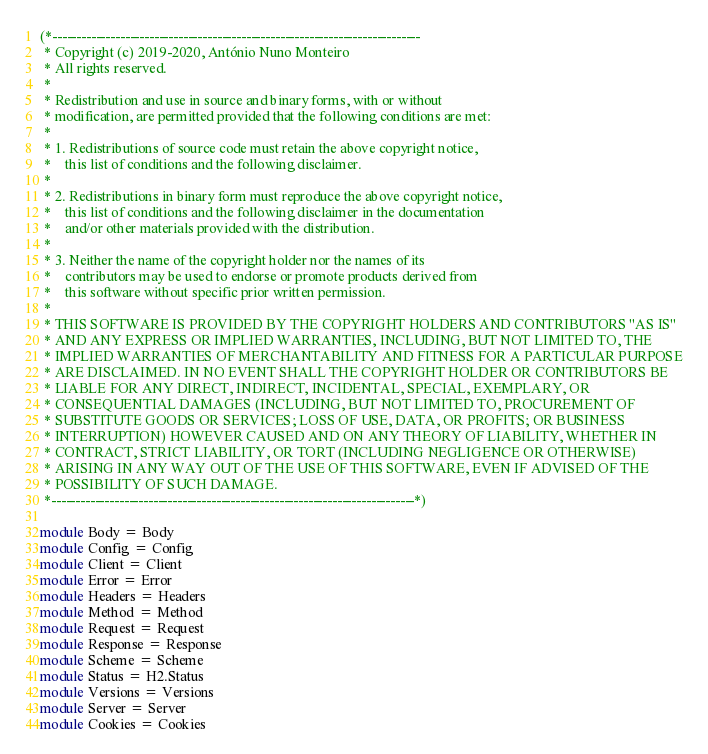<code> <loc_0><loc_0><loc_500><loc_500><_OCaml_>(*----------------------------------------------------------------------------
 * Copyright (c) 2019-2020, António Nuno Monteiro
 * All rights reserved.
 *
 * Redistribution and use in source and binary forms, with or without
 * modification, are permitted provided that the following conditions are met:
 *
 * 1. Redistributions of source code must retain the above copyright notice,
 *    this list of conditions and the following disclaimer.
 *
 * 2. Redistributions in binary form must reproduce the above copyright notice,
 *    this list of conditions and the following disclaimer in the documentation
 *    and/or other materials provided with the distribution.
 *
 * 3. Neither the name of the copyright holder nor the names of its
 *    contributors may be used to endorse or promote products derived from
 *    this software without specific prior written permission.
 *
 * THIS SOFTWARE IS PROVIDED BY THE COPYRIGHT HOLDERS AND CONTRIBUTORS "AS IS"
 * AND ANY EXPRESS OR IMPLIED WARRANTIES, INCLUDING, BUT NOT LIMITED TO, THE
 * IMPLIED WARRANTIES OF MERCHANTABILITY AND FITNESS FOR A PARTICULAR PURPOSE
 * ARE DISCLAIMED. IN NO EVENT SHALL THE COPYRIGHT HOLDER OR CONTRIBUTORS BE
 * LIABLE FOR ANY DIRECT, INDIRECT, INCIDENTAL, SPECIAL, EXEMPLARY, OR
 * CONSEQUENTIAL DAMAGES (INCLUDING, BUT NOT LIMITED TO, PROCUREMENT OF
 * SUBSTITUTE GOODS OR SERVICES; LOSS OF USE, DATA, OR PROFITS; OR BUSINESS
 * INTERRUPTION) HOWEVER CAUSED AND ON ANY THEORY OF LIABILITY, WHETHER IN
 * CONTRACT, STRICT LIABILITY, OR TORT (INCLUDING NEGLIGENCE OR OTHERWISE)
 * ARISING IN ANY WAY OUT OF THE USE OF THIS SOFTWARE, EVEN IF ADVISED OF THE
 * POSSIBILITY OF SUCH DAMAGE.
 *---------------------------------------------------------------------------*)

module Body = Body
module Config = Config
module Client = Client
module Error = Error
module Headers = Headers
module Method = Method
module Request = Request
module Response = Response
module Scheme = Scheme
module Status = H2.Status
module Versions = Versions
module Server = Server
module Cookies = Cookies
</code> 